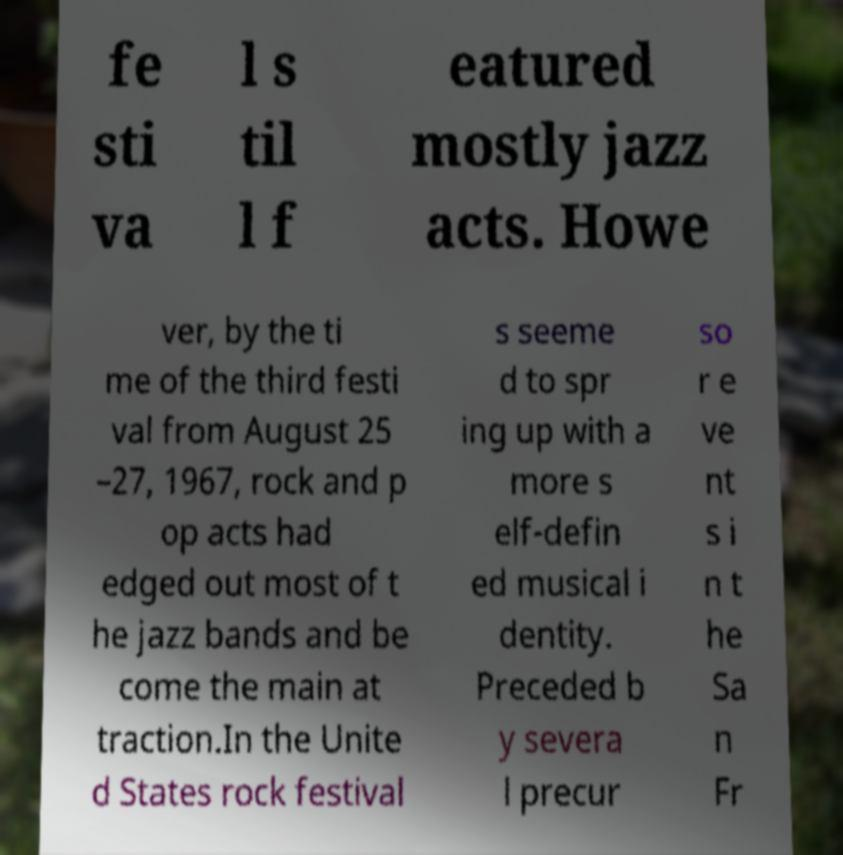Can you read and provide the text displayed in the image?This photo seems to have some interesting text. Can you extract and type it out for me? fe sti va l s til l f eatured mostly jazz acts. Howe ver, by the ti me of the third festi val from August 25 –27, 1967, rock and p op acts had edged out most of t he jazz bands and be come the main at traction.In the Unite d States rock festival s seeme d to spr ing up with a more s elf-defin ed musical i dentity. Preceded b y severa l precur so r e ve nt s i n t he Sa n Fr 